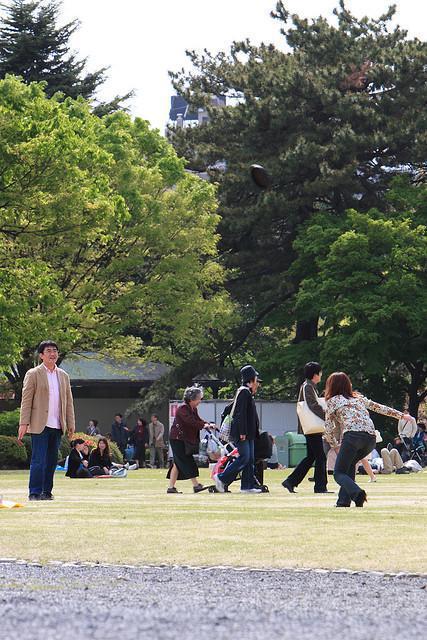What is the likely relation of the person pushing the stroller to the child in it?
Pick the correct solution from the four options below to address the question.
Options: Grandmother, mother, cousin, aunt. Grandmother. 